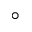<formula> <loc_0><loc_0><loc_500><loc_500>^ { \circ }</formula> 